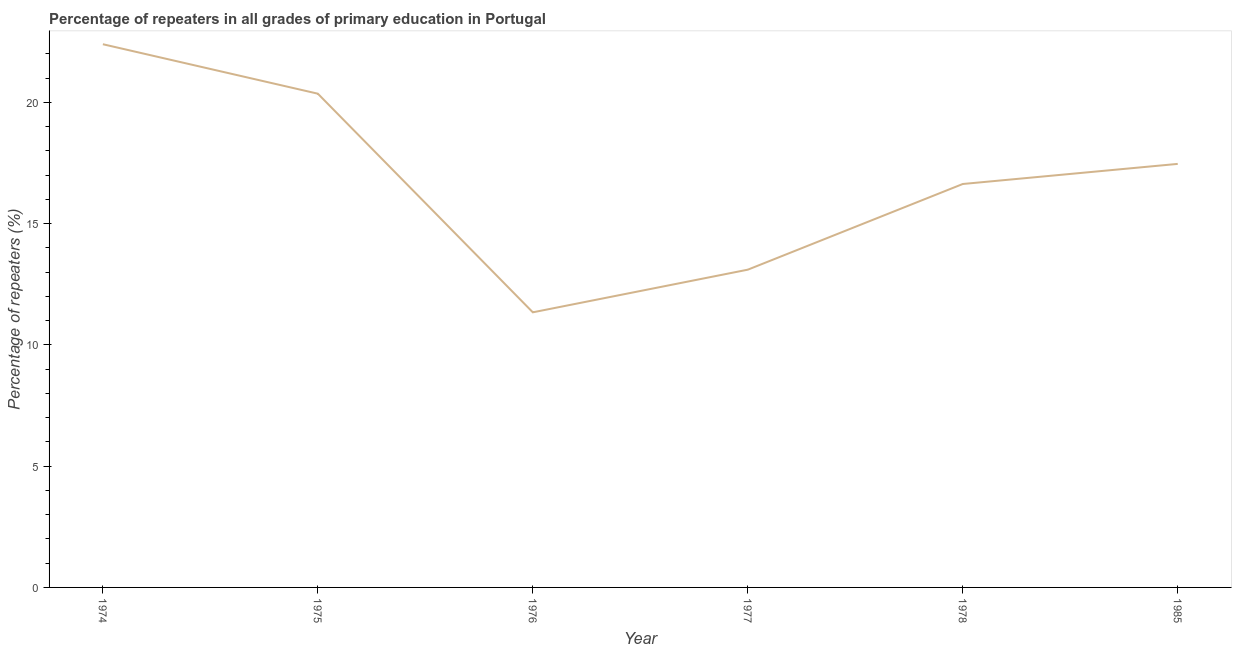What is the percentage of repeaters in primary education in 1977?
Your answer should be compact. 13.1. Across all years, what is the maximum percentage of repeaters in primary education?
Your response must be concise. 22.4. Across all years, what is the minimum percentage of repeaters in primary education?
Make the answer very short. 11.34. In which year was the percentage of repeaters in primary education maximum?
Your answer should be compact. 1974. In which year was the percentage of repeaters in primary education minimum?
Provide a short and direct response. 1976. What is the sum of the percentage of repeaters in primary education?
Give a very brief answer. 101.31. What is the difference between the percentage of repeaters in primary education in 1976 and 1985?
Keep it short and to the point. -6.12. What is the average percentage of repeaters in primary education per year?
Provide a succinct answer. 16.89. What is the median percentage of repeaters in primary education?
Ensure brevity in your answer.  17.05. What is the ratio of the percentage of repeaters in primary education in 1976 to that in 1977?
Your response must be concise. 0.87. Is the percentage of repeaters in primary education in 1974 less than that in 1985?
Make the answer very short. No. Is the difference between the percentage of repeaters in primary education in 1975 and 1977 greater than the difference between any two years?
Your answer should be compact. No. What is the difference between the highest and the second highest percentage of repeaters in primary education?
Keep it short and to the point. 2.04. Is the sum of the percentage of repeaters in primary education in 1977 and 1978 greater than the maximum percentage of repeaters in primary education across all years?
Provide a succinct answer. Yes. What is the difference between the highest and the lowest percentage of repeaters in primary education?
Offer a terse response. 11.06. In how many years, is the percentage of repeaters in primary education greater than the average percentage of repeaters in primary education taken over all years?
Your response must be concise. 3. How many lines are there?
Make the answer very short. 1. How many years are there in the graph?
Offer a very short reply. 6. Does the graph contain any zero values?
Your answer should be very brief. No. What is the title of the graph?
Keep it short and to the point. Percentage of repeaters in all grades of primary education in Portugal. What is the label or title of the Y-axis?
Keep it short and to the point. Percentage of repeaters (%). What is the Percentage of repeaters (%) of 1974?
Keep it short and to the point. 22.4. What is the Percentage of repeaters (%) in 1975?
Your answer should be compact. 20.36. What is the Percentage of repeaters (%) of 1976?
Offer a very short reply. 11.34. What is the Percentage of repeaters (%) in 1977?
Offer a very short reply. 13.1. What is the Percentage of repeaters (%) in 1978?
Ensure brevity in your answer.  16.64. What is the Percentage of repeaters (%) of 1985?
Provide a succinct answer. 17.47. What is the difference between the Percentage of repeaters (%) in 1974 and 1975?
Offer a terse response. 2.04. What is the difference between the Percentage of repeaters (%) in 1974 and 1976?
Ensure brevity in your answer.  11.06. What is the difference between the Percentage of repeaters (%) in 1974 and 1977?
Ensure brevity in your answer.  9.3. What is the difference between the Percentage of repeaters (%) in 1974 and 1978?
Your answer should be very brief. 5.76. What is the difference between the Percentage of repeaters (%) in 1974 and 1985?
Offer a terse response. 4.93. What is the difference between the Percentage of repeaters (%) in 1975 and 1976?
Your answer should be very brief. 9.02. What is the difference between the Percentage of repeaters (%) in 1975 and 1977?
Keep it short and to the point. 7.26. What is the difference between the Percentage of repeaters (%) in 1975 and 1978?
Offer a very short reply. 3.72. What is the difference between the Percentage of repeaters (%) in 1975 and 1985?
Offer a very short reply. 2.9. What is the difference between the Percentage of repeaters (%) in 1976 and 1977?
Offer a very short reply. -1.76. What is the difference between the Percentage of repeaters (%) in 1976 and 1978?
Make the answer very short. -5.29. What is the difference between the Percentage of repeaters (%) in 1976 and 1985?
Your answer should be very brief. -6.12. What is the difference between the Percentage of repeaters (%) in 1977 and 1978?
Your answer should be very brief. -3.53. What is the difference between the Percentage of repeaters (%) in 1977 and 1985?
Keep it short and to the point. -4.36. What is the difference between the Percentage of repeaters (%) in 1978 and 1985?
Offer a very short reply. -0.83. What is the ratio of the Percentage of repeaters (%) in 1974 to that in 1976?
Provide a short and direct response. 1.97. What is the ratio of the Percentage of repeaters (%) in 1974 to that in 1977?
Ensure brevity in your answer.  1.71. What is the ratio of the Percentage of repeaters (%) in 1974 to that in 1978?
Give a very brief answer. 1.35. What is the ratio of the Percentage of repeaters (%) in 1974 to that in 1985?
Provide a short and direct response. 1.28. What is the ratio of the Percentage of repeaters (%) in 1975 to that in 1976?
Your response must be concise. 1.79. What is the ratio of the Percentage of repeaters (%) in 1975 to that in 1977?
Keep it short and to the point. 1.55. What is the ratio of the Percentage of repeaters (%) in 1975 to that in 1978?
Offer a very short reply. 1.22. What is the ratio of the Percentage of repeaters (%) in 1975 to that in 1985?
Your answer should be very brief. 1.17. What is the ratio of the Percentage of repeaters (%) in 1976 to that in 1977?
Offer a terse response. 0.87. What is the ratio of the Percentage of repeaters (%) in 1976 to that in 1978?
Make the answer very short. 0.68. What is the ratio of the Percentage of repeaters (%) in 1976 to that in 1985?
Keep it short and to the point. 0.65. What is the ratio of the Percentage of repeaters (%) in 1977 to that in 1978?
Keep it short and to the point. 0.79. What is the ratio of the Percentage of repeaters (%) in 1977 to that in 1985?
Provide a short and direct response. 0.75. What is the ratio of the Percentage of repeaters (%) in 1978 to that in 1985?
Offer a terse response. 0.95. 